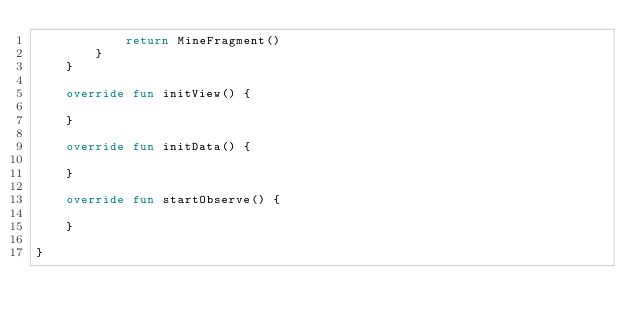<code> <loc_0><loc_0><loc_500><loc_500><_Kotlin_>            return MineFragment()
        }
    }

    override fun initView() {

    }

    override fun initData() {

    }

    override fun startObserve() {

    }

}</code> 